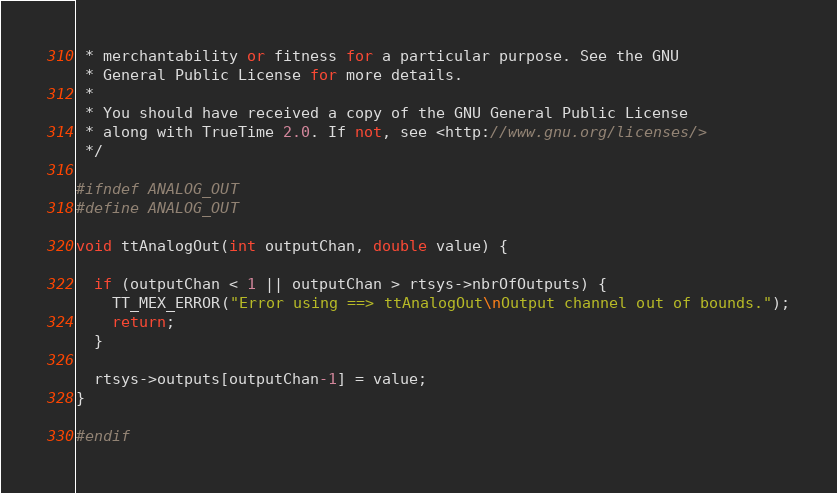Convert code to text. <code><loc_0><loc_0><loc_500><loc_500><_C++_> * merchantability or fitness for a particular purpose. See the GNU
 * General Public License for more details.
 *
 * You should have received a copy of the GNU General Public License
 * along with TrueTime 2.0. If not, see <http://www.gnu.org/licenses/>
 */

#ifndef ANALOG_OUT
#define ANALOG_OUT

void ttAnalogOut(int outputChan, double value) {
  
  if (outputChan < 1 || outputChan > rtsys->nbrOfOutputs) {
    TT_MEX_ERROR("Error using ==> ttAnalogOut\nOutput channel out of bounds.");
    return;
  }

  rtsys->outputs[outputChan-1] = value;
}

#endif
</code> 